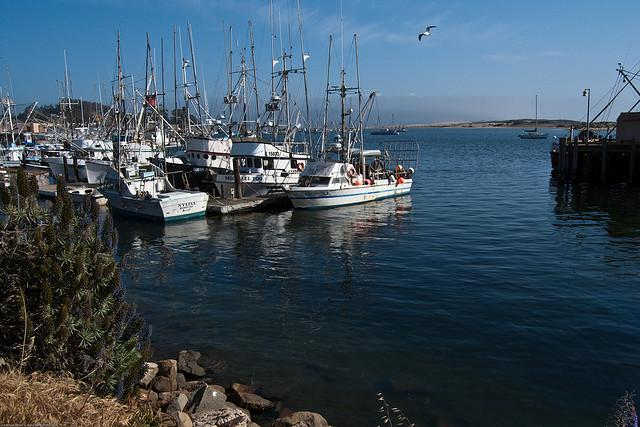Why are the boats stationary? Please explain your reasoning. docked. These boats have their sails down and are unmoving arranged around the dock. 